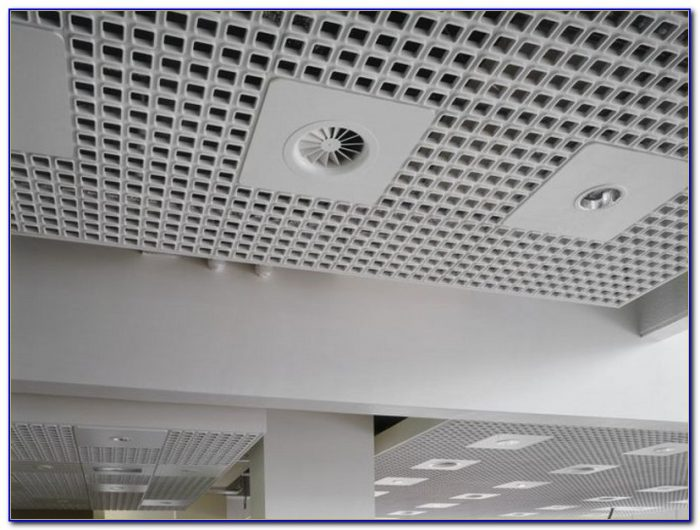Considering the design and function of the elements observed in the ceiling, what might be the purpose of the circular perforations in the ceiling tiles, and how do they contribute to the overall design and functionality of the space? The circular perforations in the ceiling tiles are likely designed to serve multiple purposes. Acoustically, they can help to absorb and reduce noise, preventing echoes and creating a more pleasant auditory environment. This is especially important in spaces like offices or public areas where noise can be distracting or overwhelming. Functionally, these perforations may also facilitate air flow, working in conjunction with the air diffuser to ensure efficient circulation of air throughout the space. Aesthetically, they contribute to a modern and clean look, integrating the necessary ventilation and lighting systems into the ceiling without disrupting the overall design theme. 